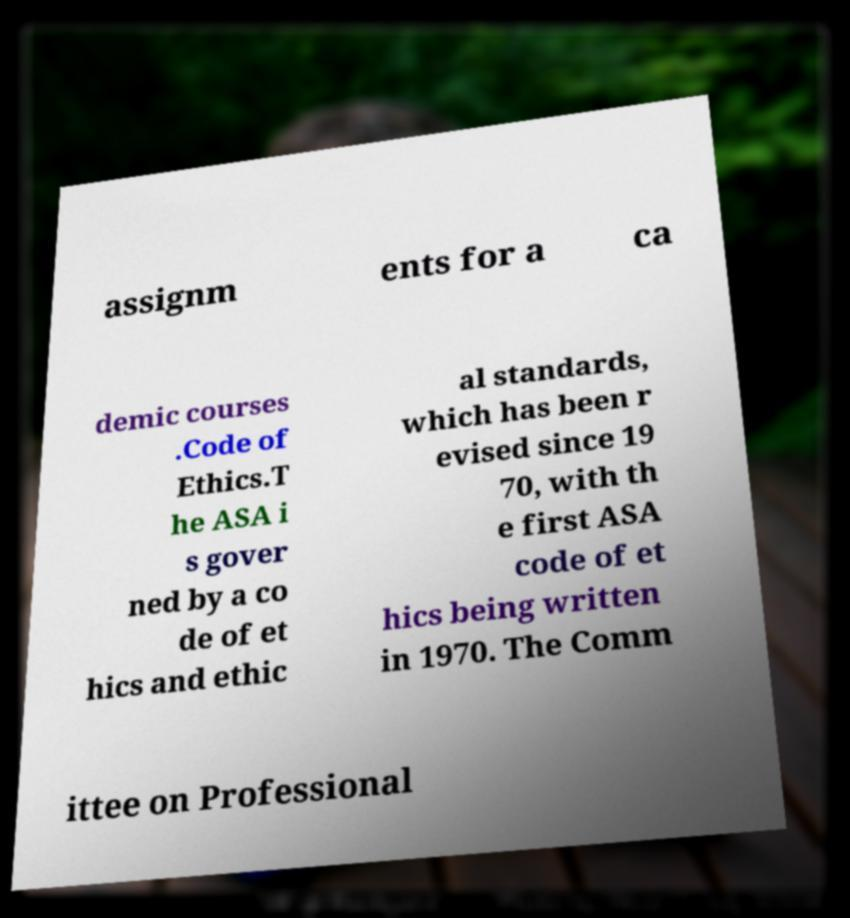Please identify and transcribe the text found in this image. assignm ents for a ca demic courses .Code of Ethics.T he ASA i s gover ned by a co de of et hics and ethic al standards, which has been r evised since 19 70, with th e first ASA code of et hics being written in 1970. The Comm ittee on Professional 